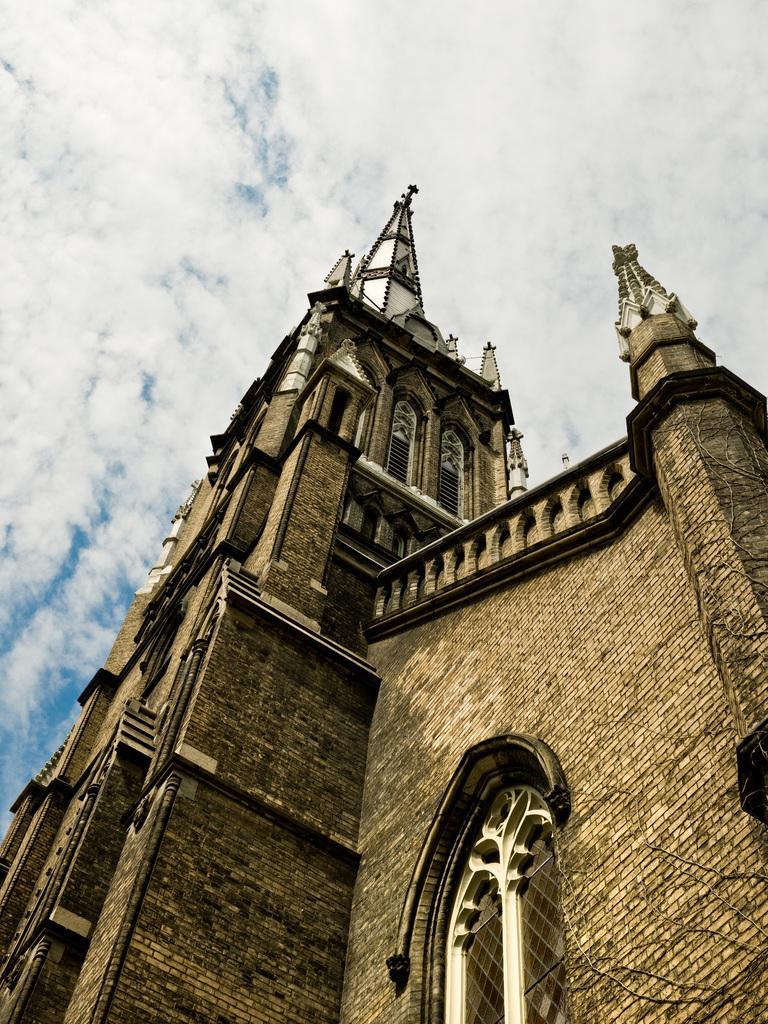Describe this image in one or two sentences. In the image we can see there is a building and the building is made up of stone bricks. There is a cloudy sky. 